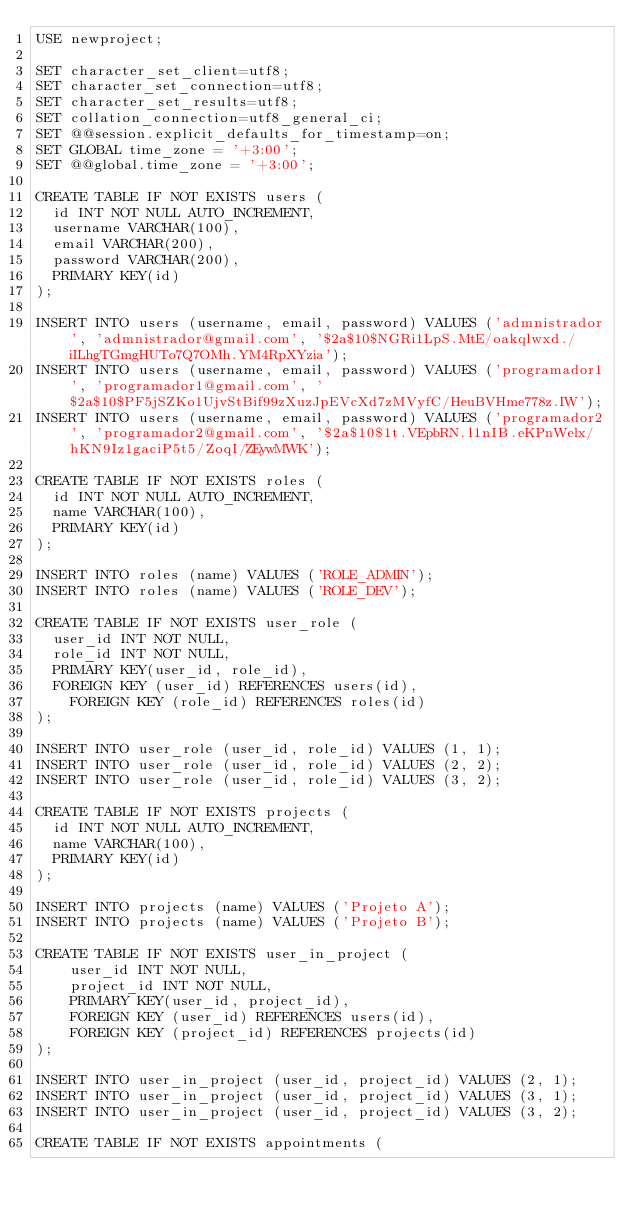<code> <loc_0><loc_0><loc_500><loc_500><_SQL_>USE newproject;

SET character_set_client=utf8;
SET character_set_connection=utf8;
SET character_set_results=utf8;
SET collation_connection=utf8_general_ci;
SET @@session.explicit_defaults_for_timestamp=on;
SET GLOBAL time_zone = '+3:00';
SET @@global.time_zone = '+3:00';

CREATE TABLE IF NOT EXISTS users (
	id INT NOT NULL AUTO_INCREMENT,
	username VARCHAR(100),
	email VARCHAR(200),
	password VARCHAR(200),
	PRIMARY KEY(id)
);

INSERT INTO users (username, email, password) VALUES ('admnistrador', 'admnistrador@gmail.com', '$2a$10$NGRi1LpS.MtE/oakqlwxd./iILhgTGmgHUTo7Q7OMh.YM4RpXYzia');
INSERT INTO users (username, email, password) VALUES ('programador1', 'programador1@gmail.com', '$2a$10$PF5jSZKo1UjvStBif99zXuzJpEVcXd7zMVyfC/HeuBVHme778z.IW');
INSERT INTO users (username, email, password) VALUES ('programador2', 'programador2@gmail.com', '$2a$10$1t.VEpbRN.l1nIB.eKPnWelx/hKN9Iz1gaciP5t5/ZoqI/ZEywMWK');

CREATE TABLE IF NOT EXISTS roles (
	id INT NOT NULL AUTO_INCREMENT,
	name VARCHAR(100),
	PRIMARY KEY(id)
);

INSERT INTO roles (name) VALUES ('ROLE_ADMIN');
INSERT INTO roles (name) VALUES ('ROLE_DEV');

CREATE TABLE IF NOT EXISTS user_role (
	user_id INT NOT NULL,
	role_id INT NOT NULL,
	PRIMARY KEY(user_id, role_id),
	FOREIGN KEY (user_id) REFERENCES users(id),
    FOREIGN KEY (role_id) REFERENCES roles(id)
);

INSERT INTO user_role (user_id, role_id) VALUES (1, 1);
INSERT INTO user_role (user_id, role_id) VALUES (2, 2);
INSERT INTO user_role (user_id, role_id) VALUES (3, 2);

CREATE TABLE IF NOT EXISTS projects (
	id INT NOT NULL AUTO_INCREMENT,
	name VARCHAR(100),
	PRIMARY KEY(id)
);

INSERT INTO projects (name) VALUES ('Projeto A');
INSERT INTO projects (name) VALUES ('Projeto B');

CREATE TABLE IF NOT EXISTS user_in_project (
    user_id INT NOT NULL,
    project_id INT NOT NULL,
    PRIMARY KEY(user_id, project_id),
    FOREIGN KEY (user_id) REFERENCES users(id),
    FOREIGN KEY (project_id) REFERENCES projects(id)
);

INSERT INTO user_in_project (user_id, project_id) VALUES (2, 1);
INSERT INTO user_in_project (user_id, project_id) VALUES (3, 1);
INSERT INTO user_in_project (user_id, project_id) VALUES (3, 2);

CREATE TABLE IF NOT EXISTS appointments (</code> 